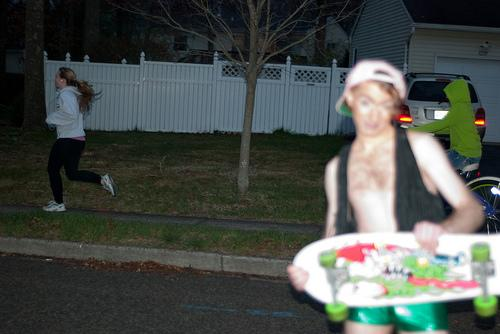Describe the type of fence and its color in the image. There is a tall white plastic fence with boards that appears to enclose a lawn. Mention the key elements and colors visible in the image. Key elements include a skateboard (white and yellow), a fence (white), a patch of grass (green), and a woman's jacket (white). Mention the type and color of the pants the jogging woman is wearing. The woman is wearing black pants while jogging on the sidewalk. Briefly describe the activity involving the man wearing a pink cap. The man in a pink cap, black vest, and green shorts is carrying a white and yellow skateboard. Talk about the color and condition of the tree in the picture. A small tree with no leaves appears to be lifeless, with bare branches spreading out. Provide a detailed description of the main character in the image. A man with a hair chest, black vest, pink cap, and bright green shorts is holding a white skateboard with yellow wheels. Narrate the action performed by a woman in the picture. A woman with dark blond hair, wearing a white jacket and black pants, is jogging down the gray concrete sidewalk. List three objects and one event that can be seen in the image. A white SUV parked in a driveway, a small tree without leaves, a yellow house with a white garage, and a child riding a bicycle. Describe the person on a bike and their clothing. A child wearing a green hoodie is riding a bicycle on the sidewalk. Describe the scene taking place on the sidewalk. A woman in a white jacket is jogging, while a child wearing a green hoodie rides a bicycle on the concrete sidewalk beside her. Find the blue bird sitting on the fence. No, it's not mentioned in the image. Observe the two boys wearing yellow hats. There is only one boy wearing a hat, and it's pink, not yellow. Spot the brown grass surrounding the sidewalk. The grass in the image is green, not brown. Look for a woman with short blonde hair walking on the sidewalk. The woman in the image has long brown hair and she is jogging, not walking. The tree in the image has many branches full of leaves. The tree in the image is a small tree without leaves. Can you identify a man riding a skateboard in the image? There is no man riding a skateboard in the image, instead, there is a boy holding a skateboard. Notice the boy wearing a red hoodie and riding a bicycle. There is a child riding a bicycle, but he is wearing a green hoodie, not a red one. Locate the red car parked in the driveway. The image has a white car parked in the driveway, not a red one. See the black fence enclosing the yard. The fence in the image is a tall white fence, not a black one. Find a woman wearing a blue dress while running. There is a woman running, but she is wearing a white jacket and black pants, not a blue dress. 